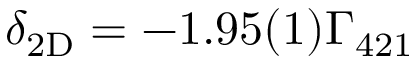Convert formula to latex. <formula><loc_0><loc_0><loc_500><loc_500>{ \delta _ { 2 D } } = - 1 . 9 5 ( 1 ) { \Gamma _ { 4 2 1 } }</formula> 